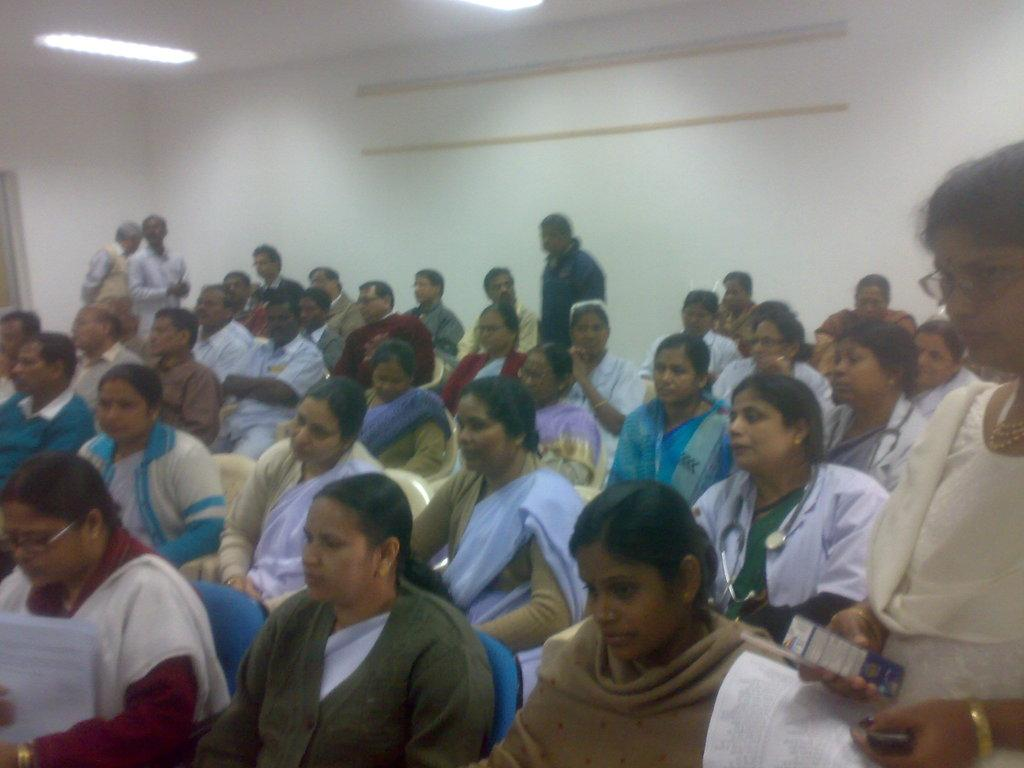How many people are standing in the image? There are four people standing in the image. What are two of the people holding? One person is holding papers, and another person is holding a box. What can be seen in the background of the image? There is a group of people sitting in the background, and there is a wall visible as well. What else can be observed in the image? There are lights visible in the image. What type of fan is being used by one of the people in the image? There is no fan present in the image. Can you tell me which person's elbow is visible in the image? There is no mention of elbows or any specific body parts in the provided facts, so it cannot be determined which person's elbow is visible. 